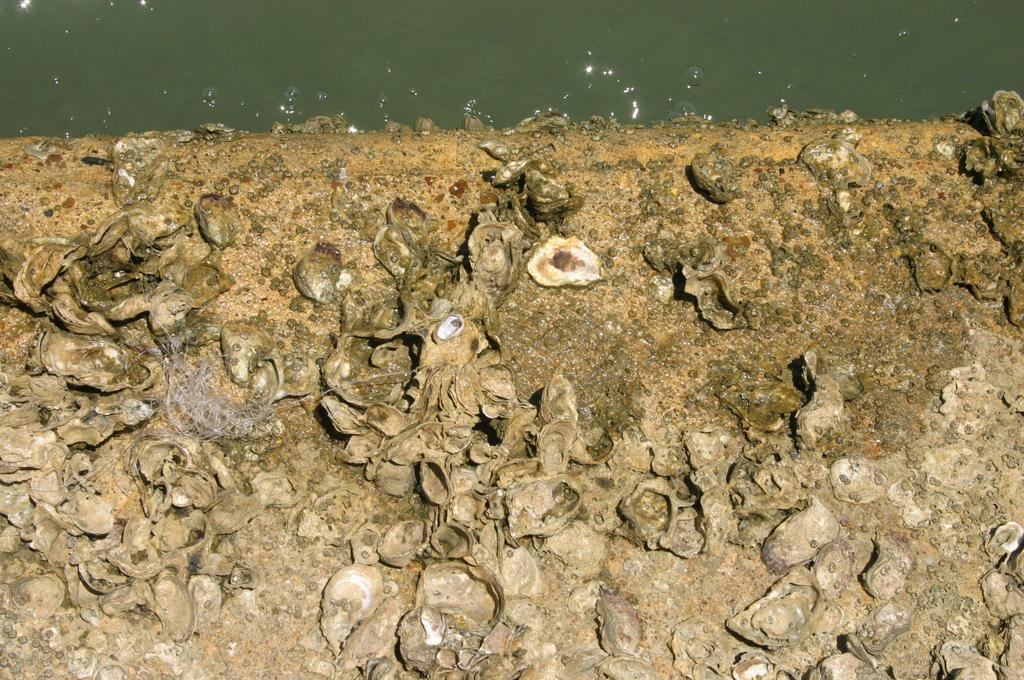What objects can be seen on the ground in the image? There are shells on the ground in the image. What natural element is visible at the top of the image? There is water visible at the top of the image. What type of committee is meeting near the water in the image? There is no committee present in the image, nor is there any indication of a meeting taking place. 